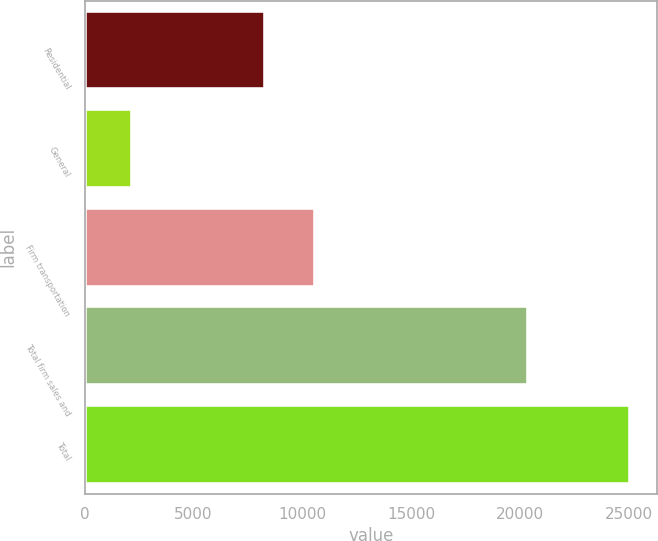Convert chart to OTSL. <chart><loc_0><loc_0><loc_500><loc_500><bar_chart><fcel>Residential<fcel>General<fcel>Firm transportation<fcel>Total firm sales and<fcel>Total<nl><fcel>8296<fcel>2184<fcel>10580.5<fcel>20353<fcel>25029<nl></chart> 